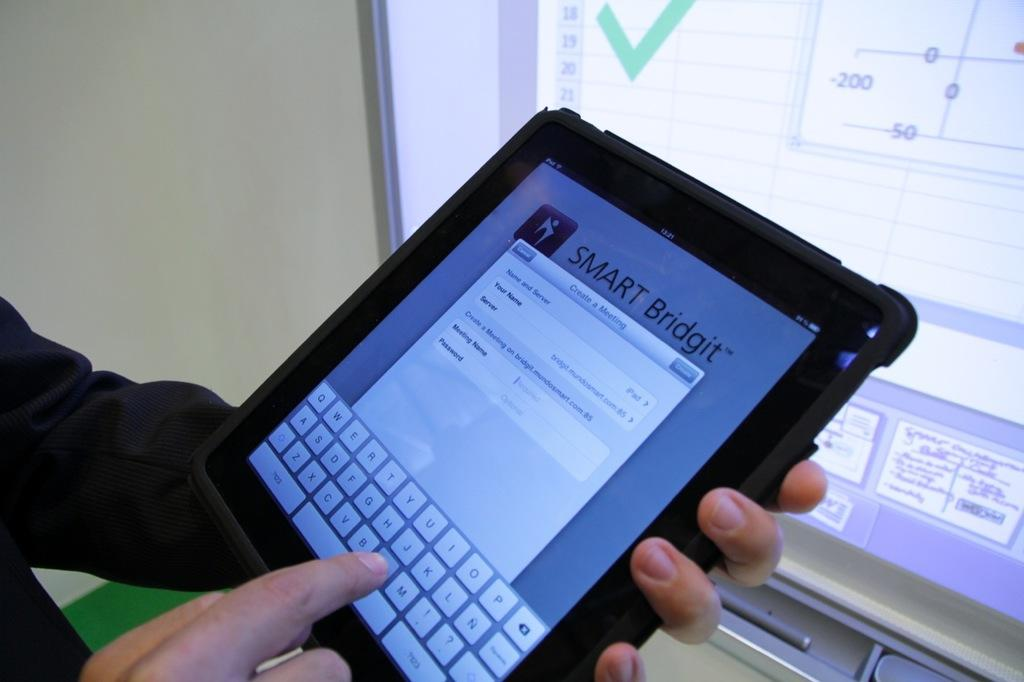What is the main subject of the image? There is a human in the image. What is the human holding in his hand? The human is holding a tab in his hand. What is the human doing with the tab? The human is typing on the tab. What can be seen on the tab's screen? There is a display on the tab's screen. What is visible in the background of the image? There is a wall visible in the image. How many chairs are visible in the image? There are no chairs visible in the image. What type of sound can be heard coming from the thunder in the image? There is no thunder present in the image. 